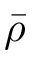<formula> <loc_0><loc_0><loc_500><loc_500>\bar { \rho }</formula> 